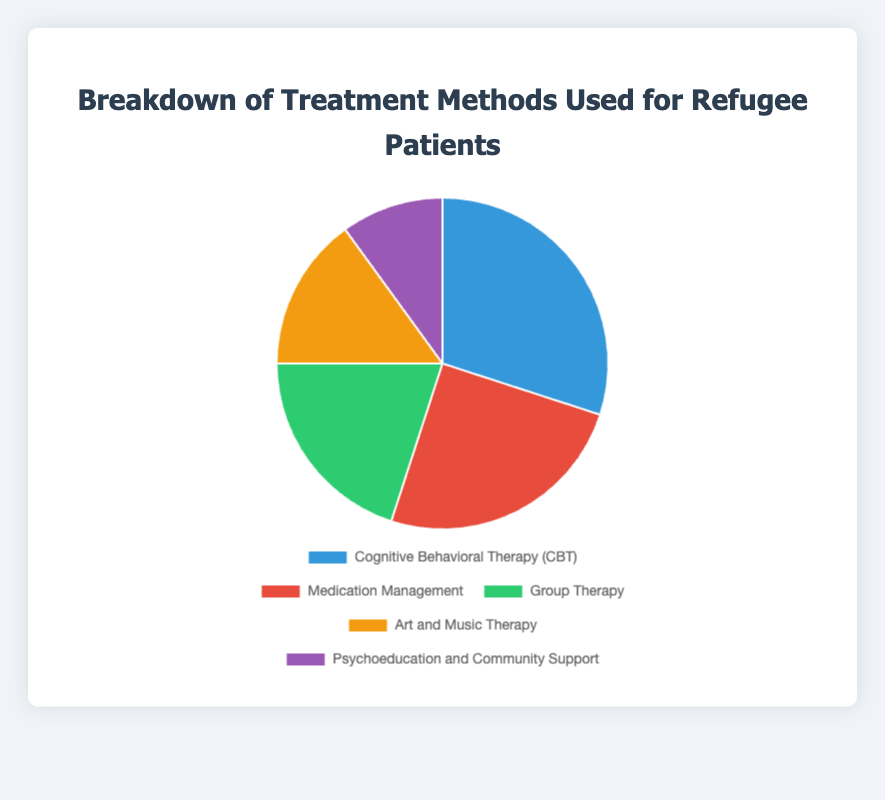What treatment method is used the most in refugee patients? The pie chart shows the breakdown of treatment methods by percentage. The largest segment represents Cognitive Behavioral Therapy (CBT) at 30%, making it the most-used method.
Answer: Cognitive Behavioral Therapy (CBT) Which treatment method has the smallest percentage? By examining the pie chart segments and their corresponding percentages, the smallest segment is for Psychoeducation and Community Support at 10%.
Answer: Psychoeducation and Community Support What is the combined percentage of Medication Management and Group Therapy? Medication Management has 25%, and Group Therapy has 20%. Adding these together gives 25% + 20% = 45%.
Answer: 45% How does the percentage of Art and Music Therapy compare to the percentage of CBT? Art and Music Therapy has 15%, while CBT has 30%. Comparing the two, 15% is less than 30%.
Answer: Art and Music Therapy is less What is the difference in percentage between Group Therapy and Psychoeducation and Community Support? Group Therapy is at 20%, and Psychoeducation and Community Support is at 10%. The difference is calculated as 20% - 10% = 10%.
Answer: 10% If we combine the percentages of all therapies except CBT, what is the total percentage? The percentages for the other therapies are: Medication Management (25%), Group Therapy (20%), Art and Music Therapy (15%), and Psychoeducation and Community Support (10%). The sum is 25% + 20% + 15% + 10% = 70%.
Answer: 70% Which method is represented by the green segment in the pie chart? From the visual attributes, the color green corresponds to Group Therapy. Therefore, Group Therapy is represented by the green segment.
Answer: Group Therapy By how much does the use of Medication Management exceed the use of Psychoeducation and Community Support? Medication Management is at 25%, and Psychoeducation and Community Support is at 10%. The excess can be calculated as 25% - 10% = 15%.
Answer: 15% Which treatment method is represented by the red segment in the pie chart? Looking at the visual attributes, the red segment represents Medication Management.
Answer: Medication Management 